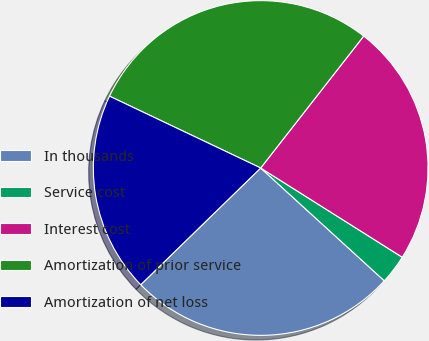Convert chart to OTSL. <chart><loc_0><loc_0><loc_500><loc_500><pie_chart><fcel>In thousands<fcel>Service cost<fcel>Interest cost<fcel>Amortization of prior service<fcel>Amortization of net loss<nl><fcel>25.94%<fcel>2.82%<fcel>23.4%<fcel>28.49%<fcel>19.34%<nl></chart> 